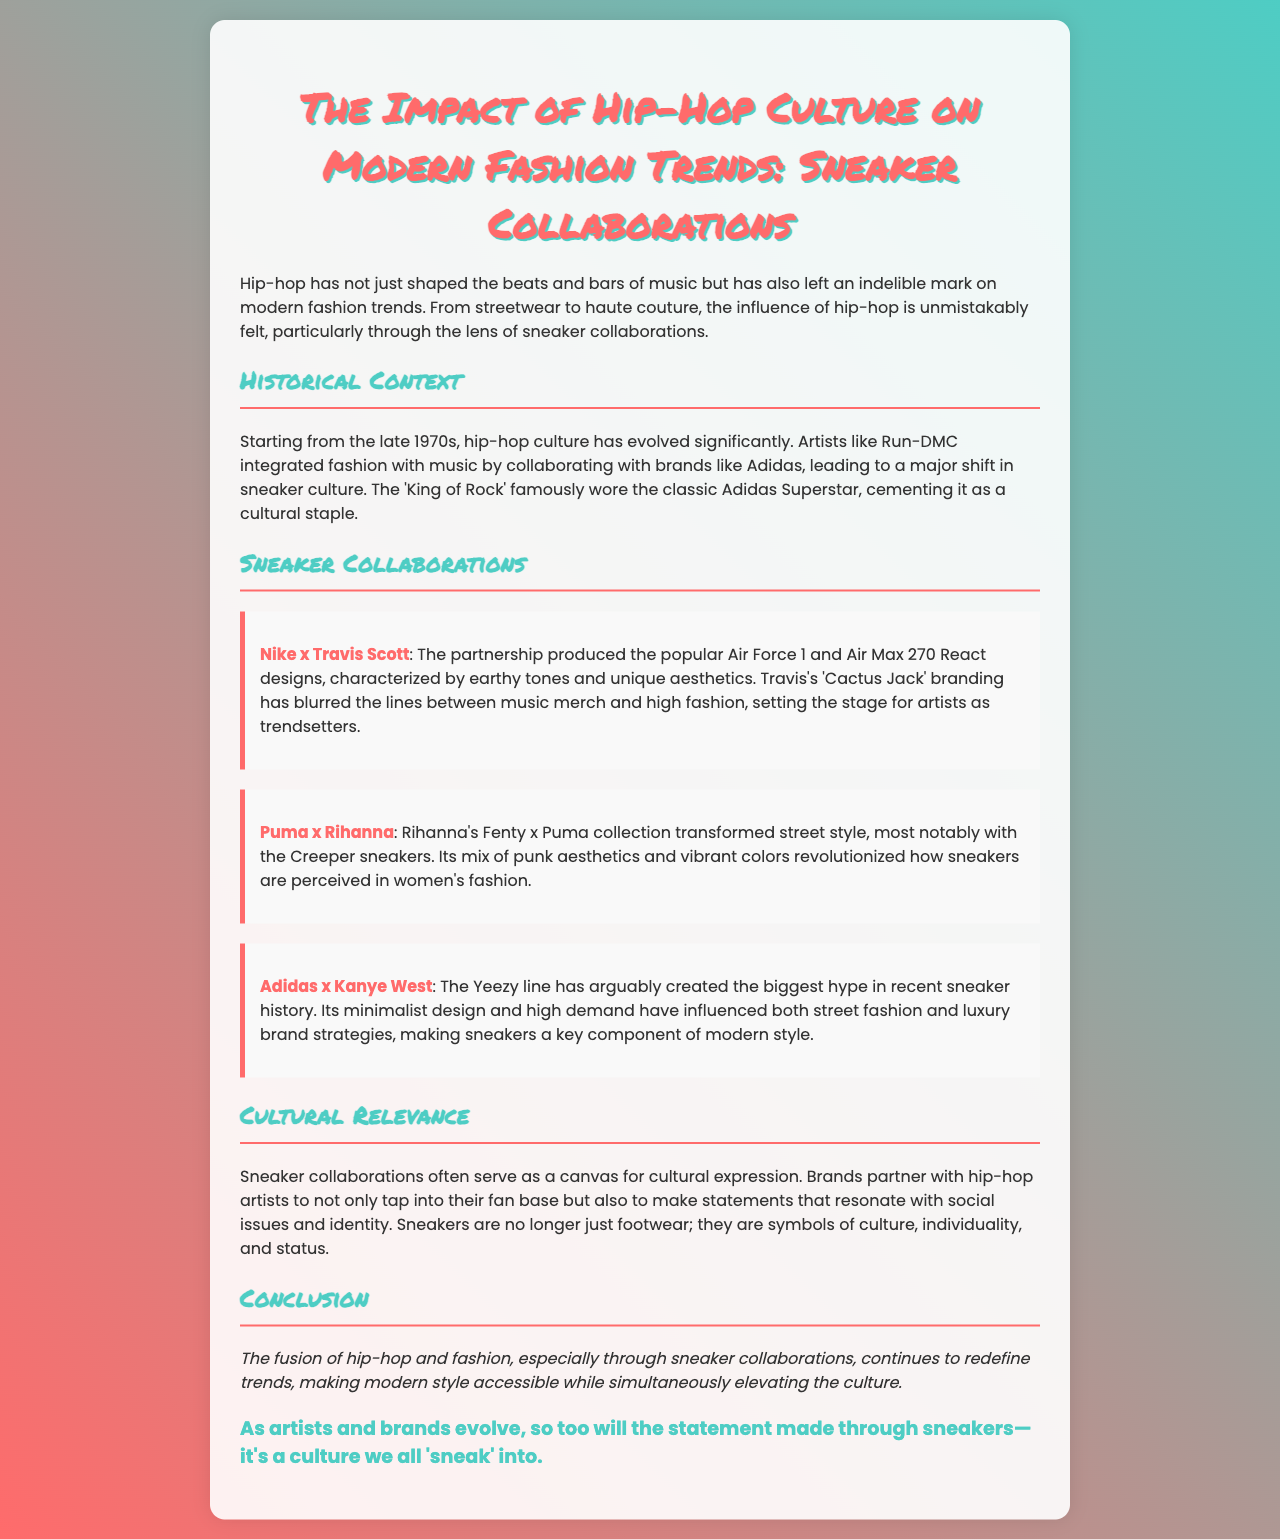What year did hip-hop culture start evolving? The document states that hip-hop culture began to evolve from the late 1970s.
Answer: late 1970s Which sneaker brand collaborated with Travis Scott? The document mentions Nike as the brand that collaborated with Travis Scott.
Answer: Nike What unique elements characterize Travis Scott's sneaker designs? The paragraph about Nike x Travis Scott describes the designs as characterized by earthy tones and unique aesthetics.
Answer: earthy tones and unique aesthetics Who transformed street style with her Fenty x Puma collection? The document credits Rihanna with transforming street style through her collaboration with Puma.
Answer: Rihanna What is the name of Kanye West's sneaker line? The document refers to Kanye West's sneaker line as Yeezy.
Answer: Yeezy How do sneaker collaborations reflect cultural expression? The document explains that they serve as a canvas for cultural expression and resonate with social issues and identity.
Answer: cultural expression What is the primary impact of hip-hop on modern fashion trends according to the document? The document claims that hip-hop has redefined trends and made modern style accessible while elevating the culture.
Answer: redefine trends What is a critical aspect of the sneaker collaborations mentioned in the document? The document highlights that sneakers are no longer just footwear; they symbolize culture, individuality, and status.
Answer: symbolize culture, individuality, and status What pun is suggested at the end of the document? The concluding pun states, "it's a culture we all 'sneak' into."
Answer: it's a culture we all 'sneak' into 